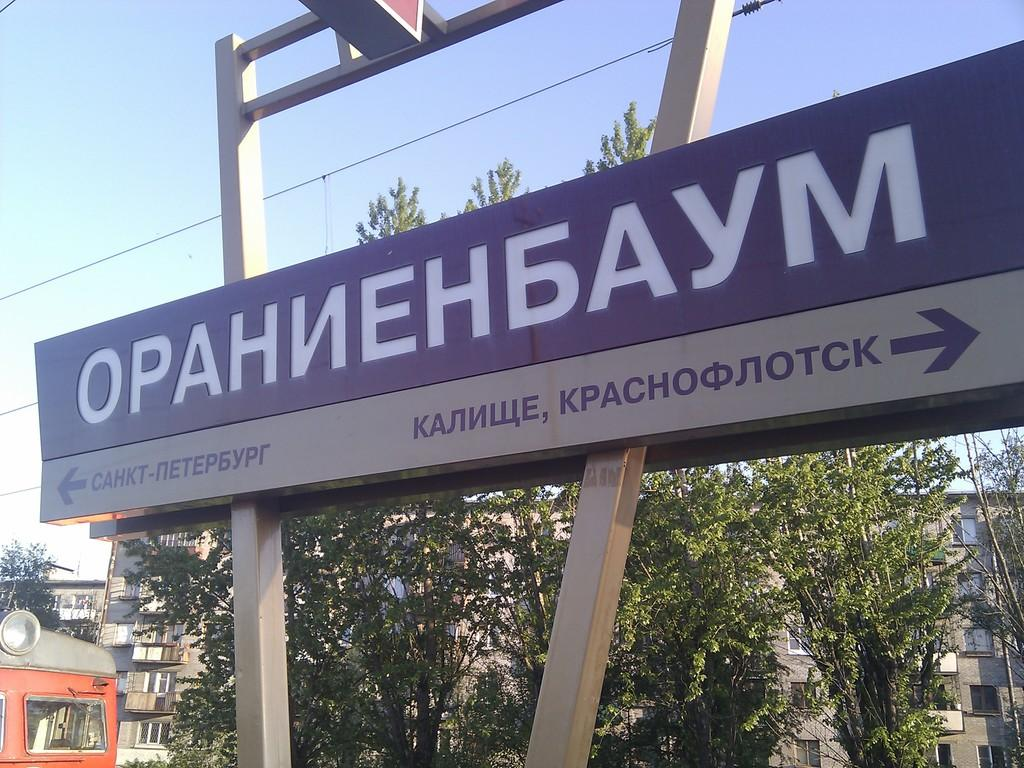What is the main object in the image? There is a board in the image. What other structures or objects can be seen in the image? There are poles, trees, wires, buildings, and an unspecified object in the image. What is the background of the image? The sky is visible in the background of the image. How many men are visible in the image? There are no men present in the image. Is it raining in the image? There is no indication of rain in the image. 